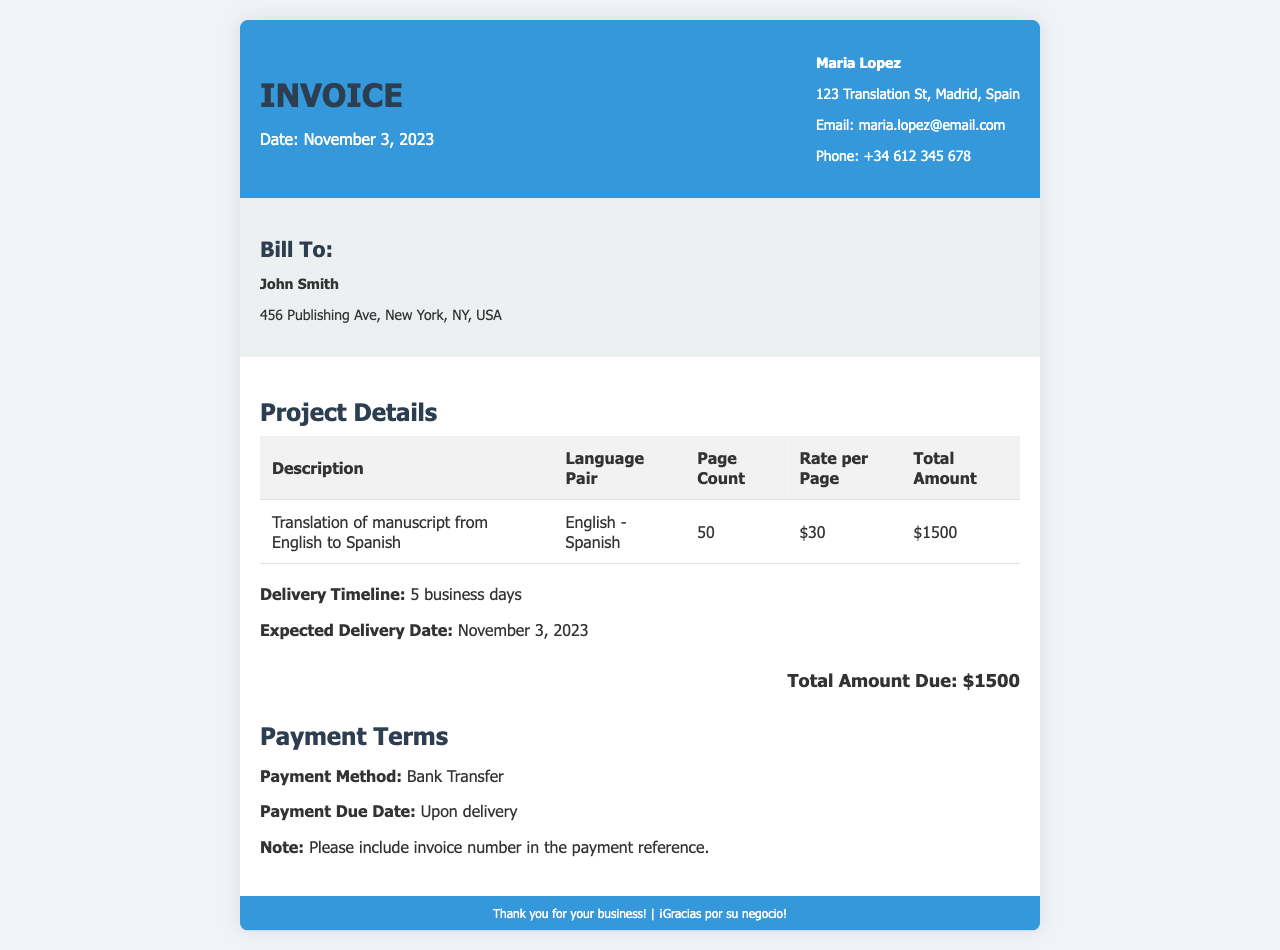What is the date of the invoice? The date of the invoice is specified in the header section.
Answer: November 3, 2023 Who is the freelancer? The freelancer's name is at the top right, indicating who issued the invoice.
Answer: Maria Lopez What is the language pair for the translation? The language pair is detailed in the project details table.
Answer: English - Spanish How many pages are in the manuscript? The page count is included in the project details section of the invoice.
Answer: 50 What is the total amount due? The total amount due is prominently displayed at the bottom of the invoice body.
Answer: $1500 What is the delivery timeline for the translation? The delivery timeline is mentioned in the project details section.
Answer: 5 business days When is the payment due? The payment due date is stated in the payment terms section.
Answer: Upon delivery What payment method is accepted? The accepted payment method is outlined in the payment terms at the bottom.
Answer: Bank Transfer 